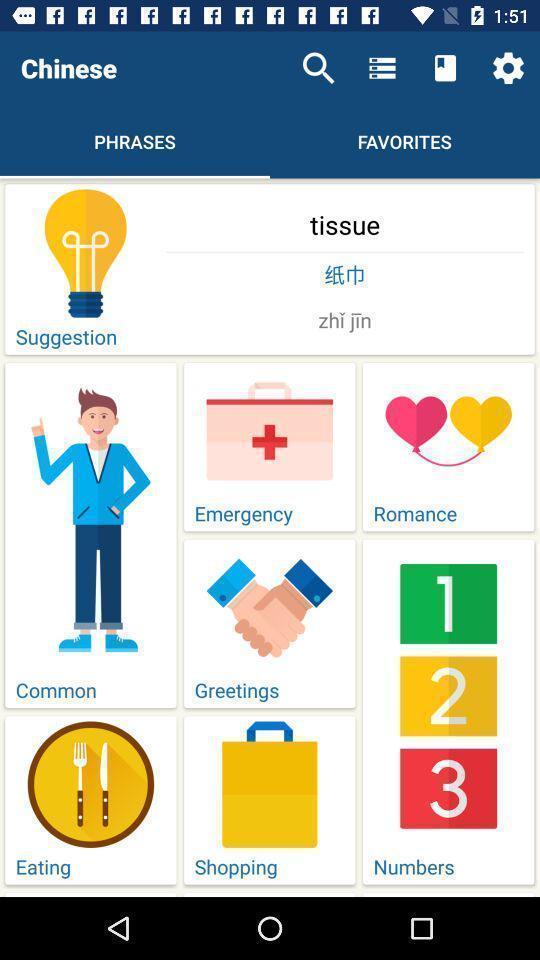Provide a detailed account of this screenshot. Screen display list of various phrases in a learning app. 